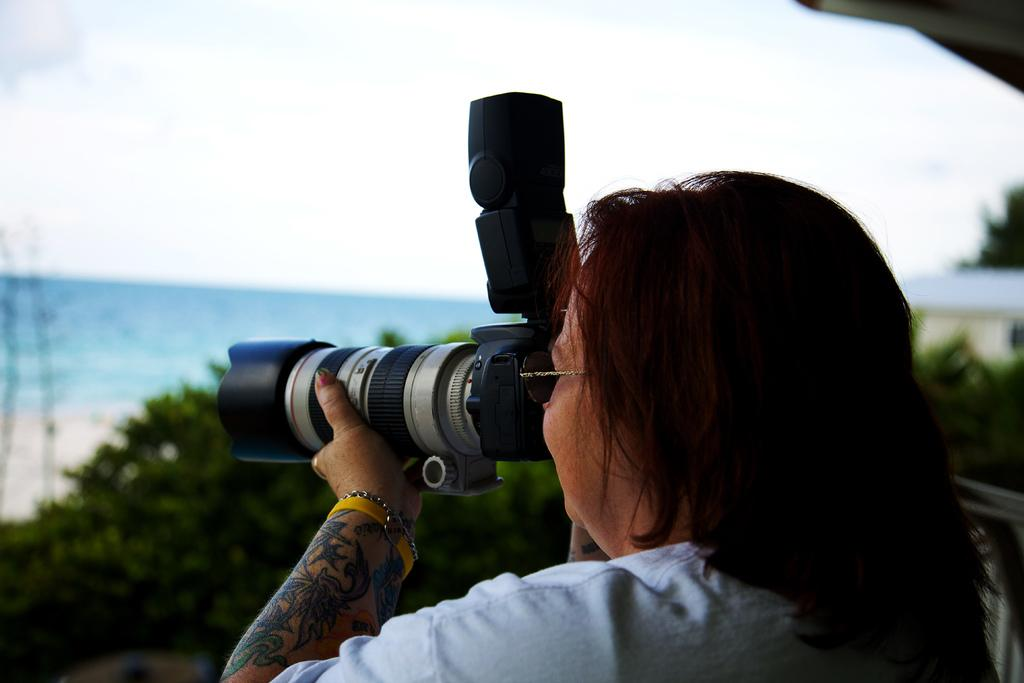What is the main subject of the image? There is a lady person in the image. What is the lady person wearing? The lady person is wearing a white T-shirt. What is the lady person holding in her hands? The lady person is holding a camera in her hands. What can be seen in the background of the image? There is water and trees visible in the background of the image. How many cacti are present in the image? There are no cacti visible in the image. What type of frame surrounds the lady person in the image? There is no frame surrounding the lady person in the image; it is a photograph or digital image without a frame. 